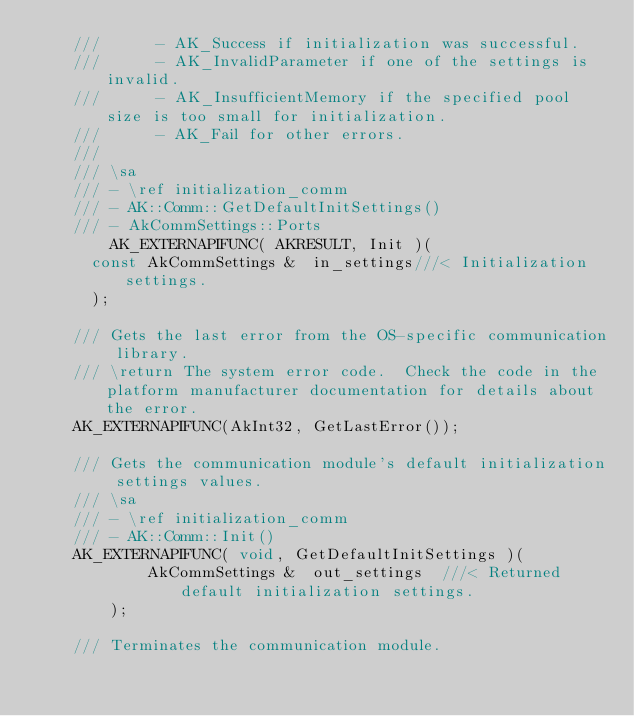Convert code to text. <code><loc_0><loc_0><loc_500><loc_500><_C_>		///      - AK_Success if initialization was successful.
		///      - AK_InvalidParameter if one of the settings is invalid.
		///      - AK_InsufficientMemory if the specified pool size is too small for initialization.
		///      - AK_Fail for other errors.
		///		
		/// \sa
		/// - \ref initialization_comm
		/// - AK::Comm::GetDefaultInitSettings()
		/// - AkCommSettings::Ports
        AK_EXTERNAPIFUNC( AKRESULT, Init )(
			const AkCommSettings &	in_settings///< Initialization settings.			
			);

		/// Gets the last error from the OS-specific communication library.
		/// \return The system error code.  Check the code in the platform manufacturer documentation for details about the error.
		AK_EXTERNAPIFUNC(AkInt32, GetLastError());

		/// Gets the communication module's default initialization settings values.
		/// \sa
		/// - \ref initialization_comm 
		/// - AK::Comm::Init()
		AK_EXTERNAPIFUNC( void, GetDefaultInitSettings )(
            AkCommSettings &	out_settings	///< Returned default initialization settings.
		    );
		
		/// Terminates the communication module.</code> 